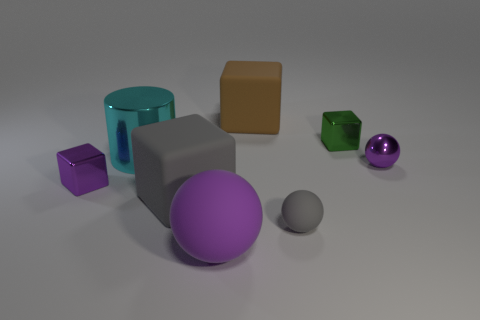What textures and materials can be observed among the objects, and how does the lighting affect their appearance? The objects display a mix of matte and glossy textures; the gray box and spheres, purple cube, and green cube have matte finishes, while the teal cylinder and purple ball are glossy, reflecting light. The lighting in the scene creates soft shadows and emphasizes the textures, adding depth and dimension to the scene. 